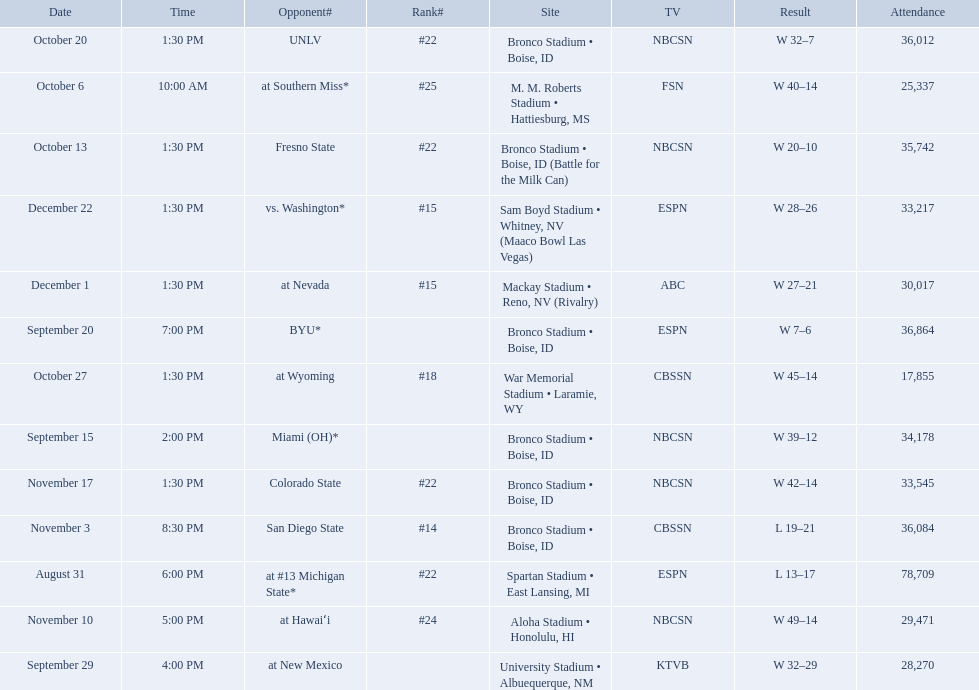What are the opponent teams of the 2012 boise state broncos football team? At #13 michigan state*, miami (oh)*, byu*, at new mexico, at southern miss*, fresno state, unlv, at wyoming, san diego state, at hawaiʻi, colorado state, at nevada, vs. washington*. How has the highest rank of these opponents? San Diego State. What are the opponents to the  2012 boise state broncos football team? At #13 michigan state*, miami (oh)*, byu*, at new mexico, at southern miss*, fresno state, unlv, at wyoming, san diego state, at hawaiʻi, colorado state, at nevada, vs. washington*. Which is the highest ranked of the teams? San Diego State. 